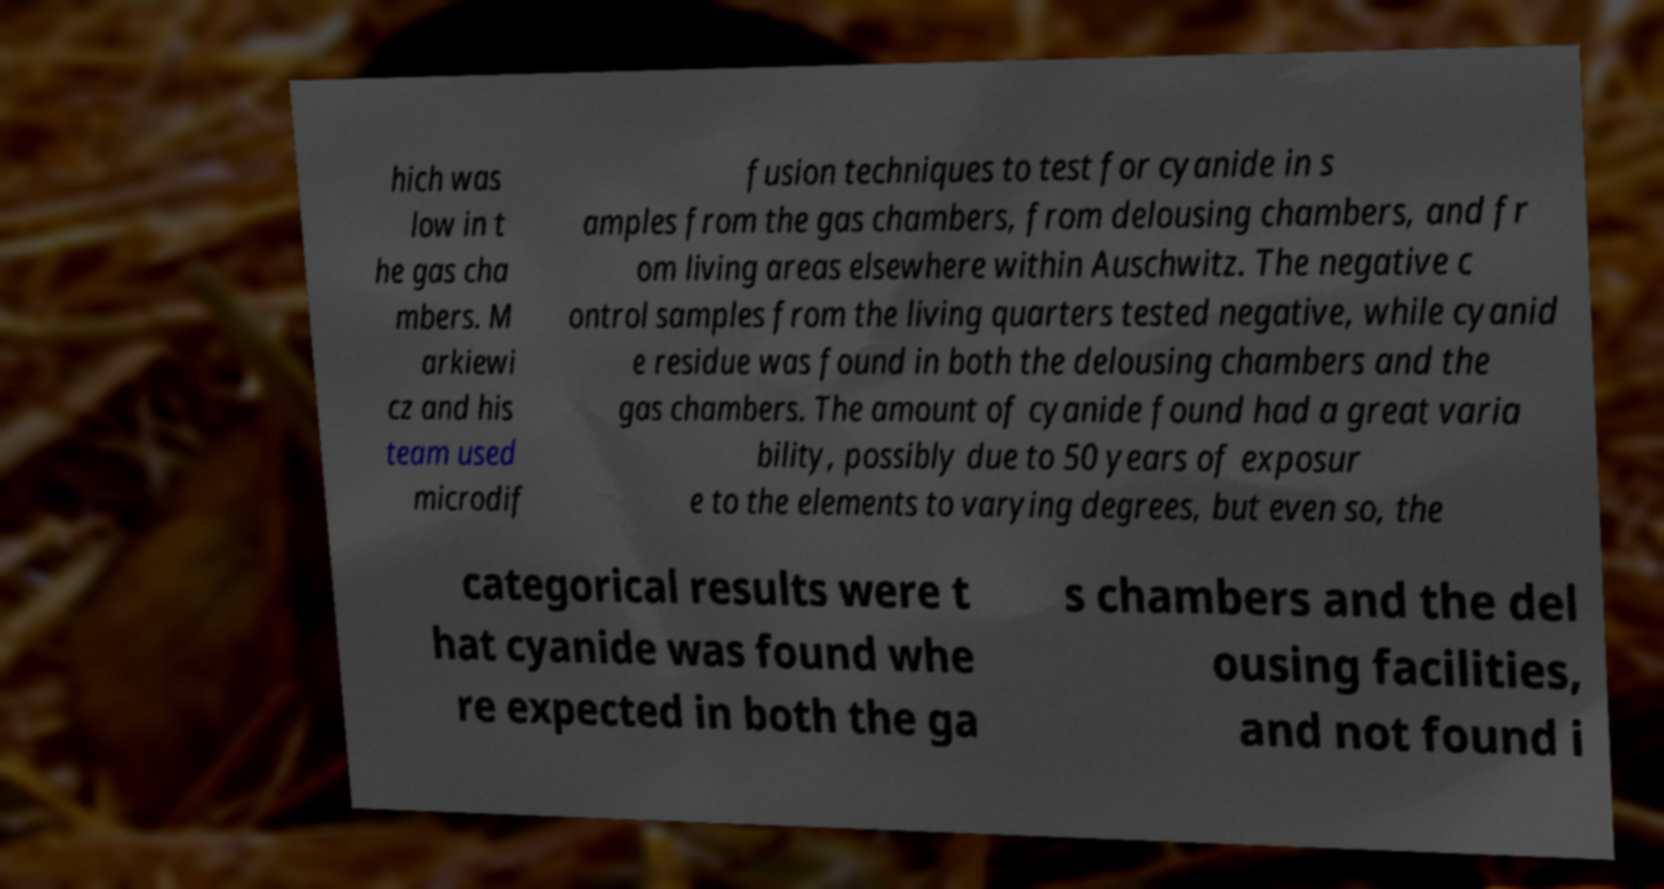What messages or text are displayed in this image? I need them in a readable, typed format. hich was low in t he gas cha mbers. M arkiewi cz and his team used microdif fusion techniques to test for cyanide in s amples from the gas chambers, from delousing chambers, and fr om living areas elsewhere within Auschwitz. The negative c ontrol samples from the living quarters tested negative, while cyanid e residue was found in both the delousing chambers and the gas chambers. The amount of cyanide found had a great varia bility, possibly due to 50 years of exposur e to the elements to varying degrees, but even so, the categorical results were t hat cyanide was found whe re expected in both the ga s chambers and the del ousing facilities, and not found i 